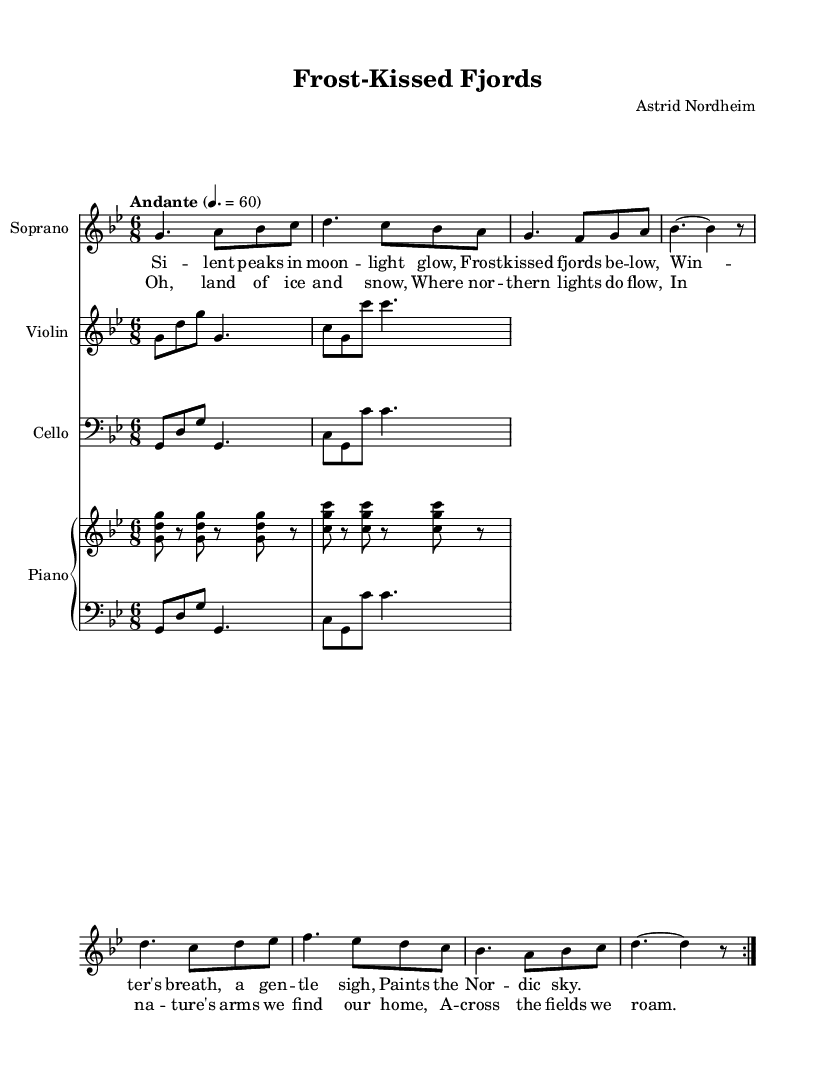What is the key signature of this music? The key signature is G minor, which has two flats (B flat and E flat).
Answer: G minor What is the time signature of this music? The time signature is 6/8, which means there are six eighth notes per measure.
Answer: 6/8 What is the tempo marking indicated in the music? The tempo marking is "Andante," which typically indicates a moderately slow tempo.
Answer: Andante What instruments are included in this piece? The piece includes Soprano, Violin, Cello, and Piano.
Answer: Soprano, Violin, Cello, Piano How many verses does the opera section contain? The opera section contains one verse and a chorus, as indicated by the lyrics structure.
Answer: One What natural element is emphasized in the lyrics? The lyrics emphasize "frost" and "winter," highlighting the beauty of the Nordic landscape.
Answer: Frost, winter What is the central theme of the chorus? The chorus celebrates nature and the connection to the land, emphasizing home and wandering in nature.
Answer: Connection to land 